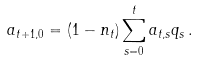<formula> <loc_0><loc_0><loc_500><loc_500>a _ { t + 1 , 0 } = ( 1 - n _ { t } ) \sum _ { s = 0 } ^ { t } a _ { t , s } q _ { s } \, .</formula> 